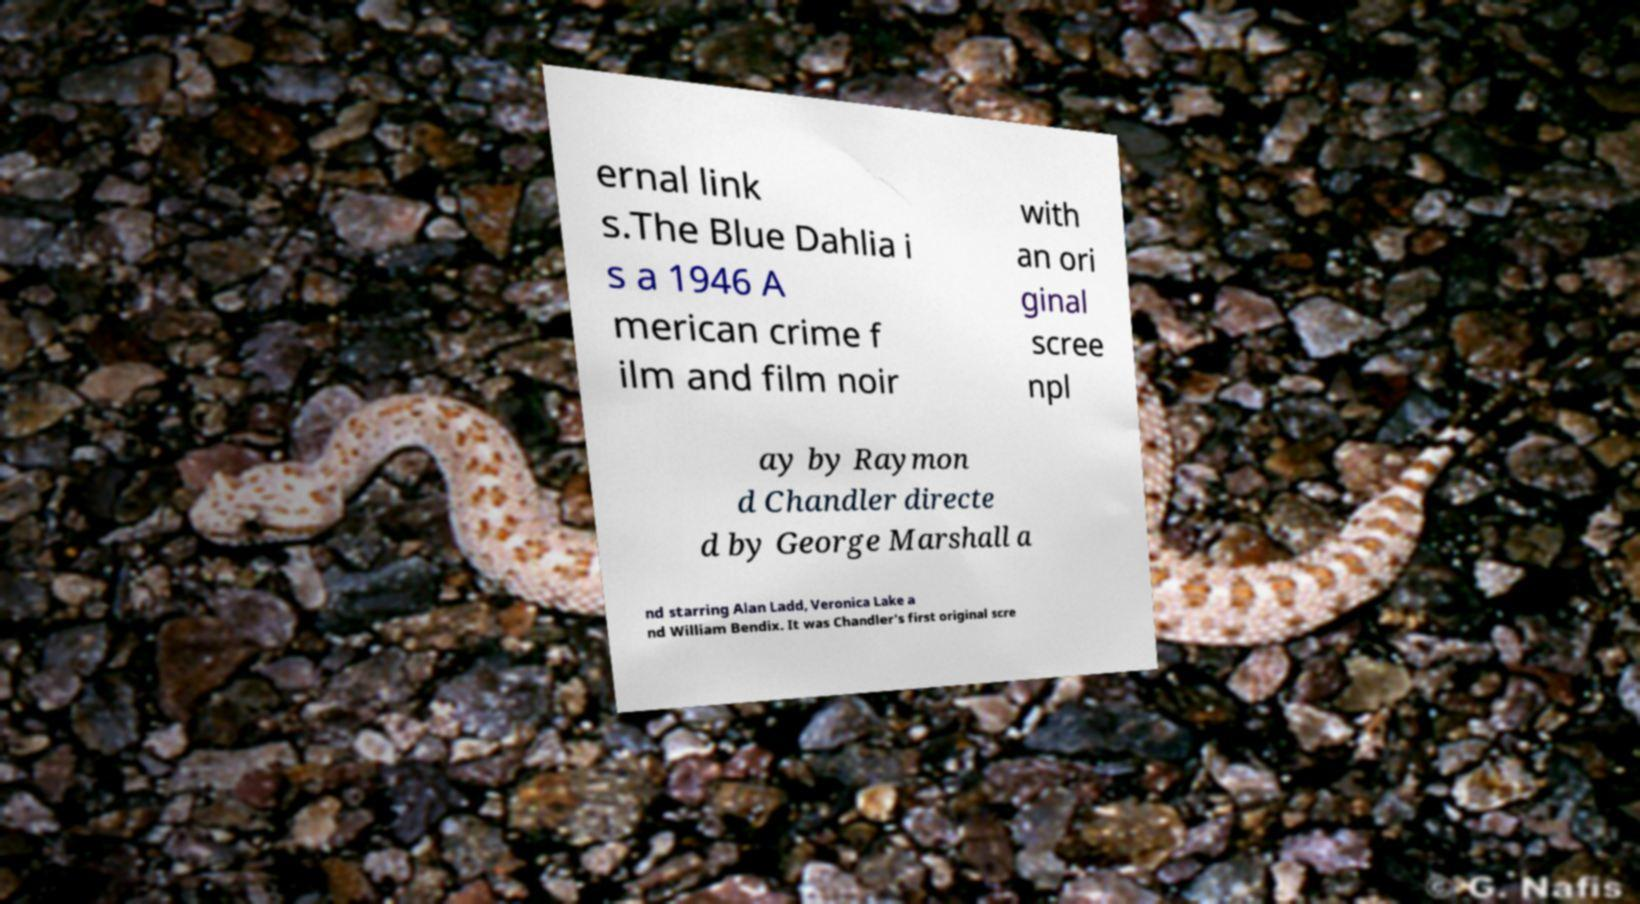Please read and relay the text visible in this image. What does it say? ernal link s.The Blue Dahlia i s a 1946 A merican crime f ilm and film noir with an ori ginal scree npl ay by Raymon d Chandler directe d by George Marshall a nd starring Alan Ladd, Veronica Lake a nd William Bendix. It was Chandler's first original scre 